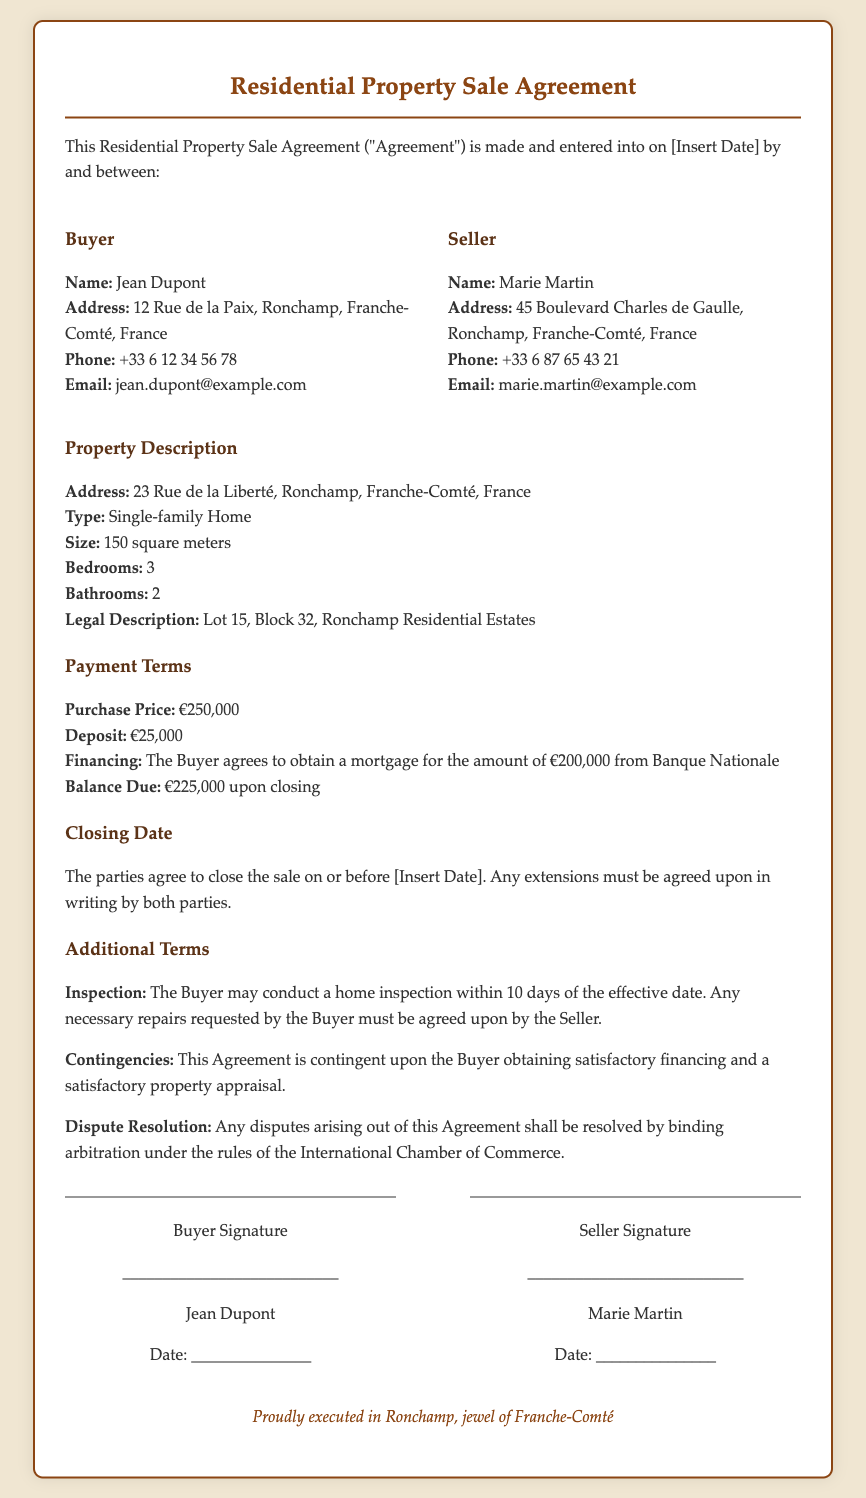what is the name of the buyer? The buyer's name is mentioned in the document, which is Jean Dupont.
Answer: Jean Dupont what is the purchase price of the property? The purchase price is specified in the payment terms section of the document as €250,000.
Answer: €250,000 how many bedrooms does the property have? The number of bedrooms is listed in the property description section of the document, which states there are 3 bedrooms.
Answer: 3 when is the closing date agreed upon? The document states that the closing date will be on or before a specified date, which is to be inserted.
Answer: [Insert Date] what is required for the home inspection? The document specifies that the Buyer may conduct a home inspection within 10 days of the effective date, and any repairs must be agreed upon by the Seller.
Answer: 10 days who is responsible for obtaining financing? The agreement states that the Buyer agrees to obtain a mortgage for the amount stated in the payment terms section.
Answer: Buyer what is the legal description of the property? The legal description of the property can be found in the property description section, which is Lot 15, Block 32, Ronchamp Residential Estates.
Answer: Lot 15, Block 32, Ronchamp Residential Estates what dispute resolution method is specified in the document? The document outlines that any disputes shall be resolved by binding arbitration under the rules of the International Chamber of Commerce.
Answer: binding arbitration what is the amount of deposit specified in the payment terms? The deposit amount is clearly stated in the payment terms section of the document as €25,000.
Answer: €25,000 who is the seller of the property? The seller's name is provided in the document, which is Marie Martin.
Answer: Marie Martin 